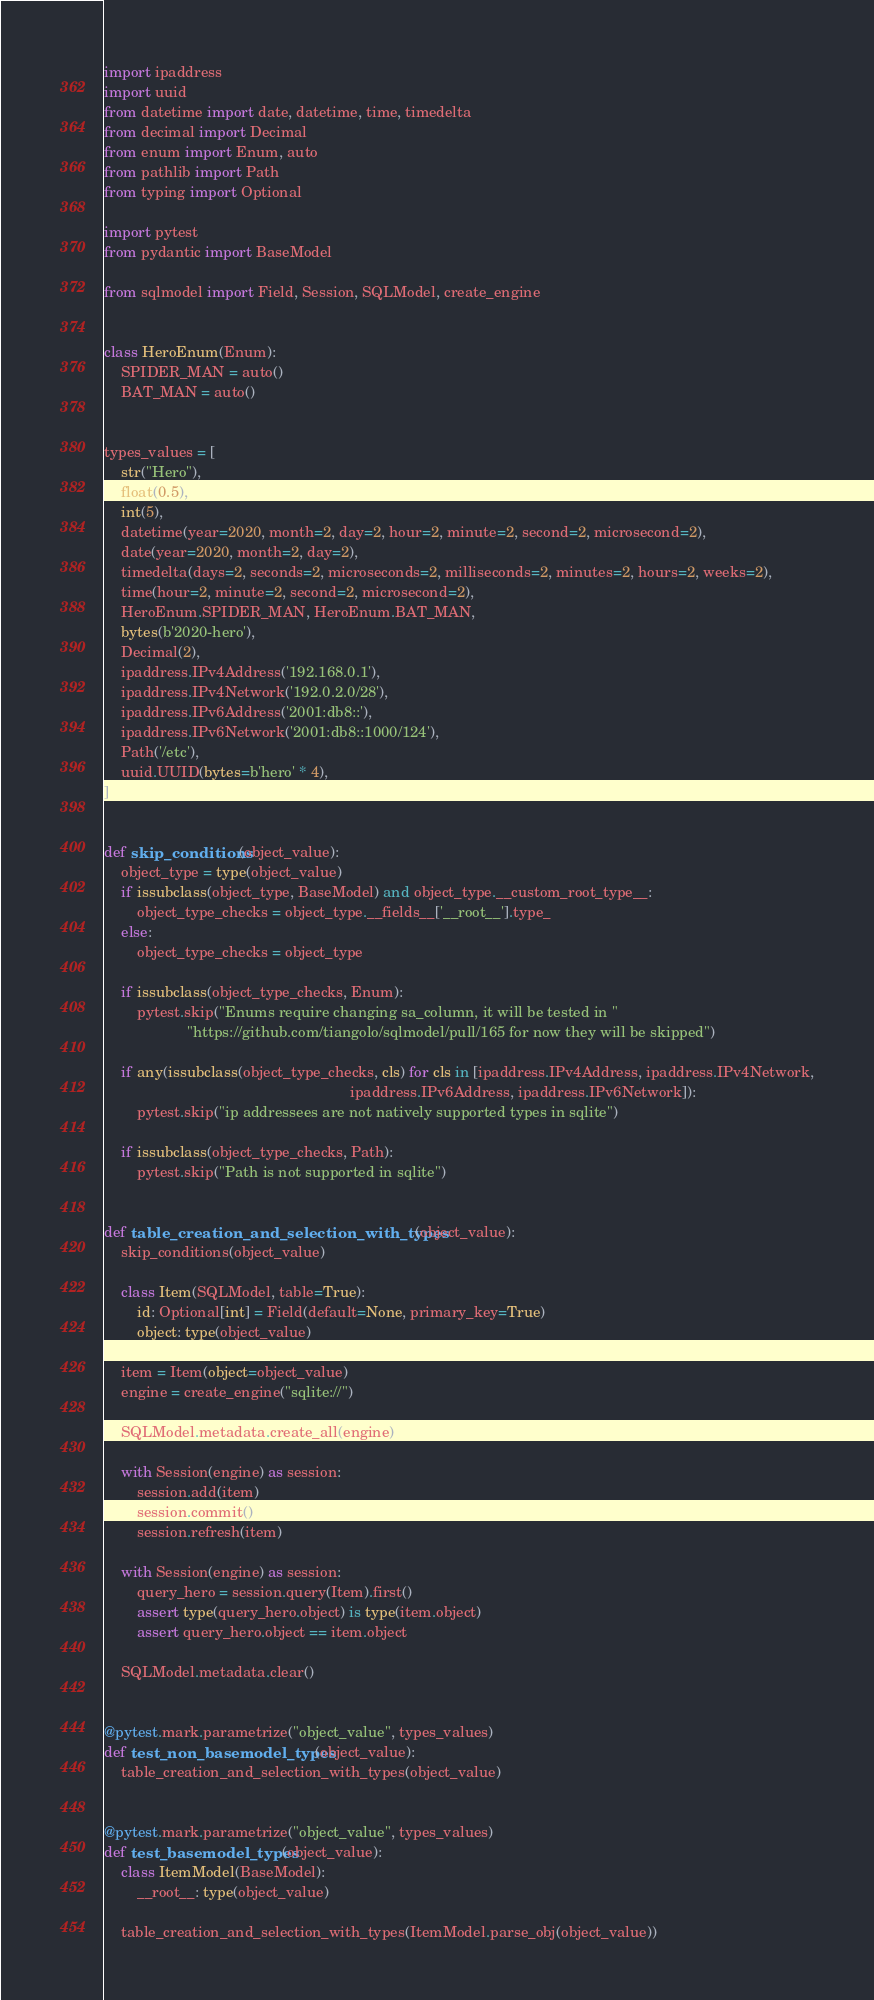Convert code to text. <code><loc_0><loc_0><loc_500><loc_500><_Python_>import ipaddress
import uuid
from datetime import date, datetime, time, timedelta
from decimal import Decimal
from enum import Enum, auto
from pathlib import Path
from typing import Optional

import pytest
from pydantic import BaseModel

from sqlmodel import Field, Session, SQLModel, create_engine


class HeroEnum(Enum):
    SPIDER_MAN = auto()
    BAT_MAN = auto()


types_values = [
    str("Hero"),
    float(0.5),
    int(5),
    datetime(year=2020, month=2, day=2, hour=2, minute=2, second=2, microsecond=2),
    date(year=2020, month=2, day=2),
    timedelta(days=2, seconds=2, microseconds=2, milliseconds=2, minutes=2, hours=2, weeks=2),
    time(hour=2, minute=2, second=2, microsecond=2),
    HeroEnum.SPIDER_MAN, HeroEnum.BAT_MAN,
    bytes(b'2020-hero'),
    Decimal(2),
    ipaddress.IPv4Address('192.168.0.1'),
    ipaddress.IPv4Network('192.0.2.0/28'),
    ipaddress.IPv6Address('2001:db8::'),
    ipaddress.IPv6Network('2001:db8::1000/124'),
    Path('/etc'),
    uuid.UUID(bytes=b'hero' * 4),
]


def skip_conditions(object_value):
    object_type = type(object_value)
    if issubclass(object_type, BaseModel) and object_type.__custom_root_type__:
        object_type_checks = object_type.__fields__['__root__'].type_
    else:
        object_type_checks = object_type

    if issubclass(object_type_checks, Enum):
        pytest.skip("Enums require changing sa_column, it will be tested in "
                    "https://github.com/tiangolo/sqlmodel/pull/165 for now they will be skipped")

    if any(issubclass(object_type_checks, cls) for cls in [ipaddress.IPv4Address, ipaddress.IPv4Network,
                                                           ipaddress.IPv6Address, ipaddress.IPv6Network]):
        pytest.skip("ip addressees are not natively supported types in sqlite")

    if issubclass(object_type_checks, Path):
        pytest.skip("Path is not supported in sqlite")


def table_creation_and_selection_with_types(object_value):
    skip_conditions(object_value)

    class Item(SQLModel, table=True):
        id: Optional[int] = Field(default=None, primary_key=True)
        object: type(object_value)

    item = Item(object=object_value)
    engine = create_engine("sqlite://")

    SQLModel.metadata.create_all(engine)

    with Session(engine) as session:
        session.add(item)
        session.commit()
        session.refresh(item)

    with Session(engine) as session:
        query_hero = session.query(Item).first()
        assert type(query_hero.object) is type(item.object)
        assert query_hero.object == item.object

    SQLModel.metadata.clear()


@pytest.mark.parametrize("object_value", types_values)
def test_non_basemodel_types(object_value):
    table_creation_and_selection_with_types(object_value)


@pytest.mark.parametrize("object_value", types_values)
def test_basemodel_types(object_value):
    class ItemModel(BaseModel):
        __root__: type(object_value)

    table_creation_and_selection_with_types(ItemModel.parse_obj(object_value))
</code> 